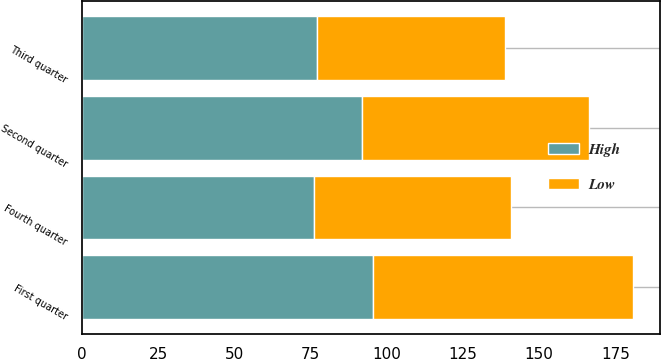Convert chart. <chart><loc_0><loc_0><loc_500><loc_500><stacked_bar_chart><ecel><fcel>First quarter<fcel>Second quarter<fcel>Third quarter<fcel>Fourth quarter<nl><fcel>High<fcel>95.5<fcel>91.85<fcel>77.03<fcel>76.2<nl><fcel>Low<fcel>85.15<fcel>74.53<fcel>61.6<fcel>64.39<nl></chart> 